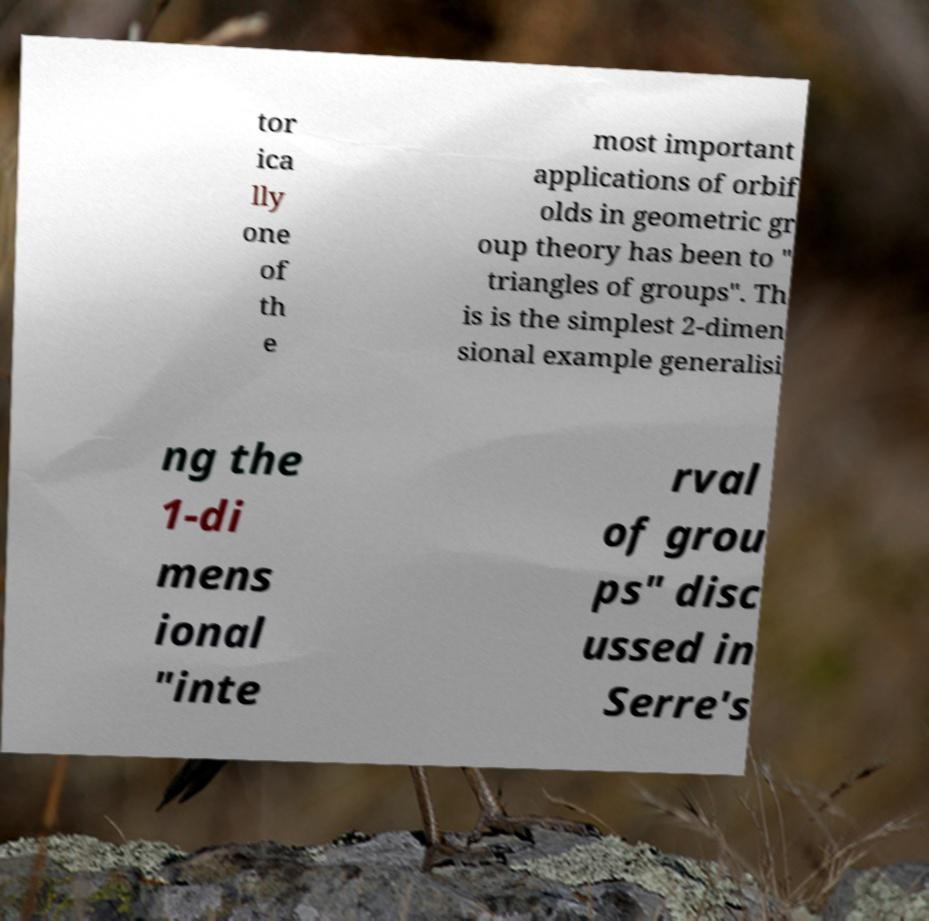Could you assist in decoding the text presented in this image and type it out clearly? tor ica lly one of th e most important applications of orbif olds in geometric gr oup theory has been to " triangles of groups". Th is is the simplest 2-dimen sional example generalisi ng the 1-di mens ional "inte rval of grou ps" disc ussed in Serre's 